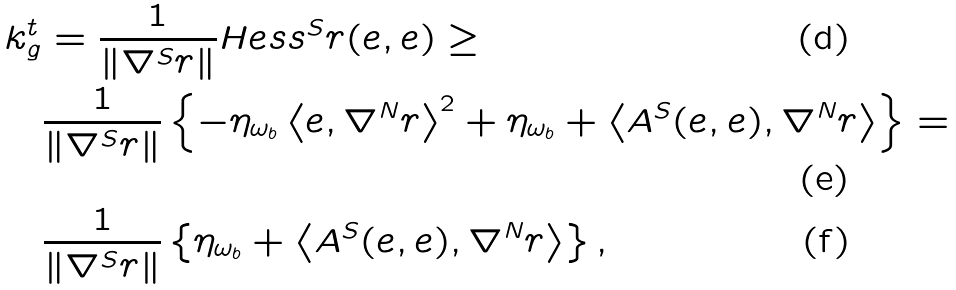Convert formula to latex. <formula><loc_0><loc_0><loc_500><loc_500>k _ { g } ^ { t } & = \frac { 1 } { \| \nabla ^ { S } r \| } H e s s ^ { S } r ( e , e ) \geq \\ & \frac { 1 } { \| \nabla ^ { S } r \| } \left \{ - \eta _ { \omega _ { b } } \left \langle e , \nabla ^ { N } r \right \rangle ^ { 2 } + \eta _ { \omega _ { b } } + \left \langle A ^ { S } ( e , e ) , \nabla ^ { N } r \right \rangle \right \} = \\ & \frac { 1 } { \| \nabla ^ { S } r \| } \left \{ \eta _ { \omega _ { b } } + \left \langle A ^ { S } ( e , e ) , \nabla ^ { N } r \right \rangle \right \} ,</formula> 